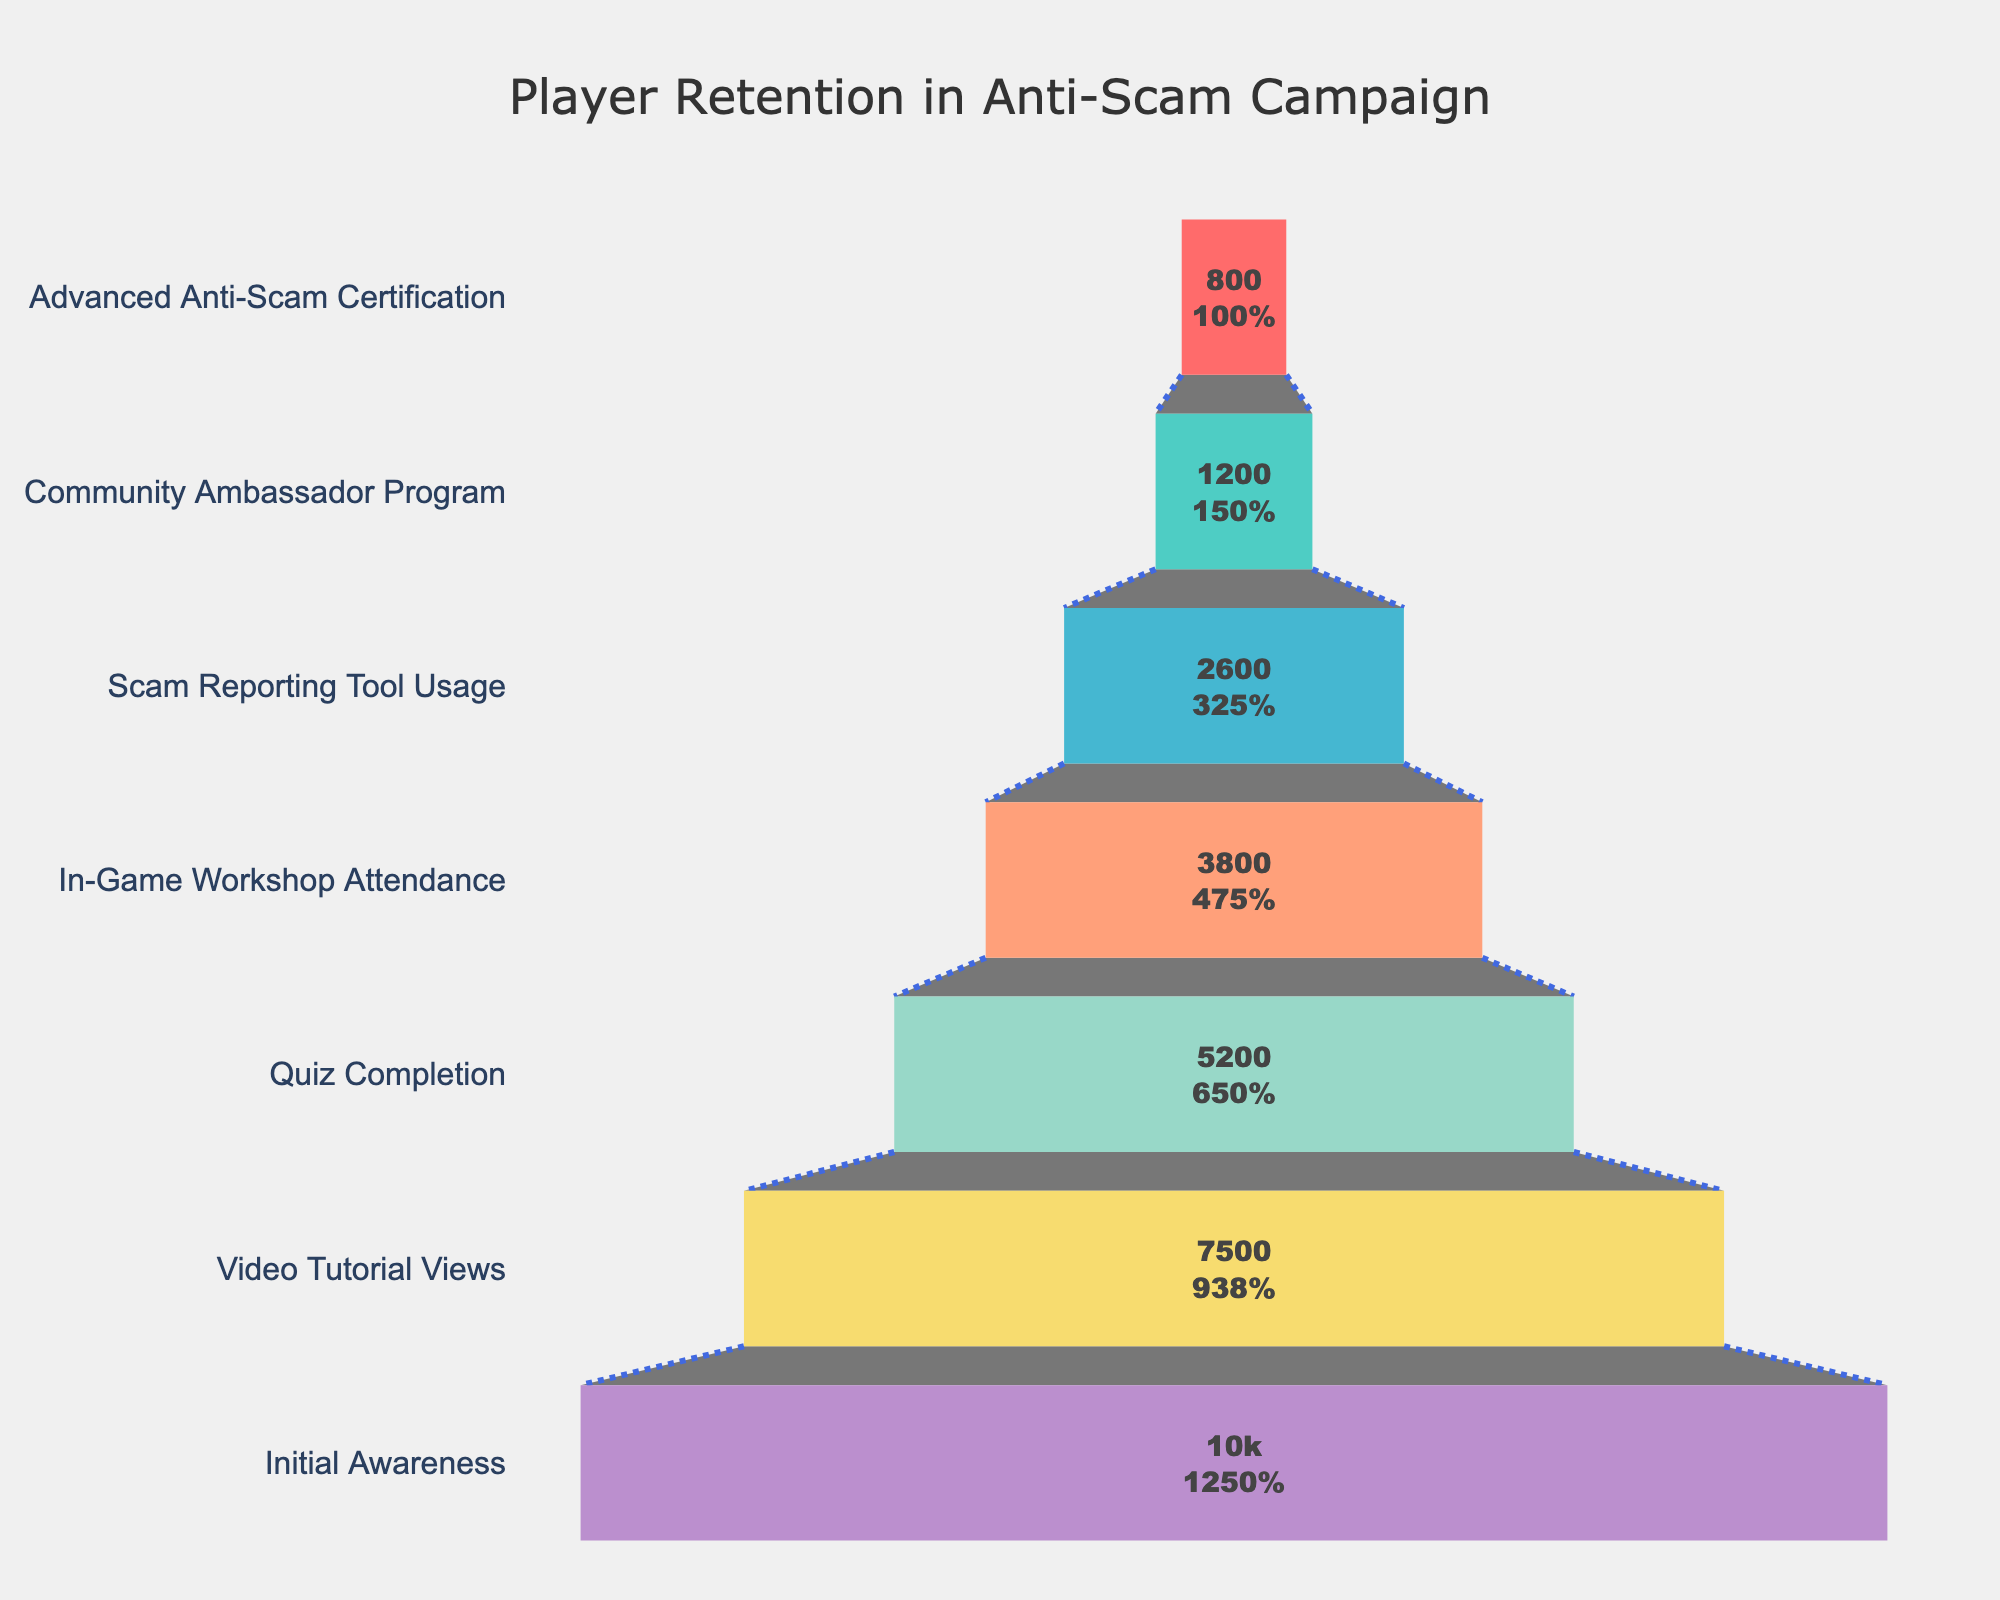What is the title of the funnel chart? The title of the chart is located at the top and center of the figure, usually in a larger and bold font to make it noticeable. In this case, the title is "Player Retention in Anti-Scam Campaign".
Answer: Player Retention in Anti-Scam Campaign How many players completed the video tutorial views stage? The funnel chart lists each stage along the y-axis, and the number of players retained at each stage is shown in text inside the funnel sections. According to the figure, 7500 players completed the Video Tutorial Views stage.
Answer: 7500 Which stage had the largest drop-off in player numbers? To determine this, one must compare the number of players between each consecutive stage and identify the largest difference. The biggest drop-off occurs between the Initial Awareness (10000) and Video Tutorial Views (7500), which is a drop of 2500 players.
Answer: Between Initial Awareness and Video Tutorial Views How many stages are depicted in the funnel chart? Stages are listed along the y-axis. By counting each entry, we can see there are seven stages depicted.
Answer: Seven What is the difference in the number of players between the Quiz Completion and Community Ambassador Program stages? To find this, subtract the number of players in the Community Ambassador Program stage from the Quiz Completion stage. That is, 5200 - 1200 = 4000 players.
Answer: 4000 What percentage of players who initially showed awareness made it to the Scam Reporting Tool Usage stage? According to the chart, the percentage is shown alongside the player count inside each funnel section. For the Scam Reporting Tool Usage stage, it is 2600 out of 10000. 2600/10000 * 100 = 26%.
Answer: 26% Which stage has the fewest number of players? The stage with the fewest players can be identified by locating the smallest number in the funnel chart. The Advanced Anti-Scam Certification stage has the fewest players, with 800.
Answer: Advanced Anti-Scam Certification What is the average number of players across all stages? First, sum the number of players at each stage: 10000 + 7500 + 5200 + 3800 + 2600 + 1200 + 800 = 30100. There are seven stages, so the average is 30100 / 7 ≈ 4300 players.
Answer: Approximately 4300 How many players attended the in-game workshop? The number of players at each stage is displayed inside the funnel sections. For the In-Game Workshop Attendance stage, it shows 3800 players.
Answer: 3800 What is the percentage decrease in player numbers from the Scam Reporting Tool Usage to the Community Ambassador Program stage? Calculate the percentage decrease using the formula: ((2600 - 1200) / 2600) * 100. The result is approximately 53.85%.
Answer: Approximately 53.85% 